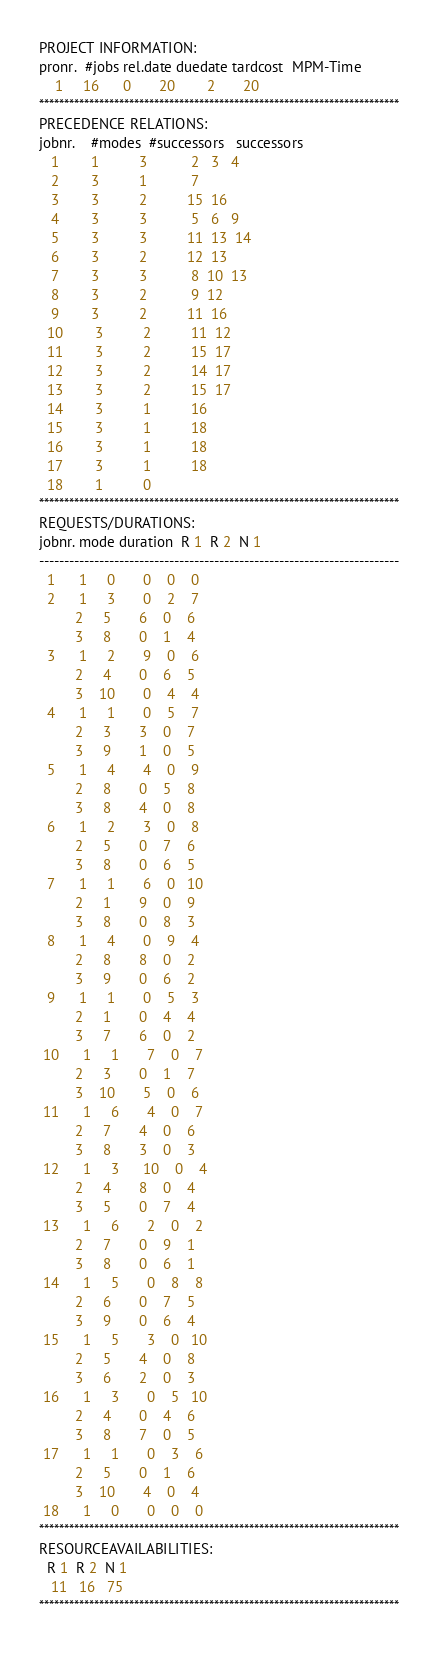Convert code to text. <code><loc_0><loc_0><loc_500><loc_500><_ObjectiveC_>PROJECT INFORMATION:
pronr.  #jobs rel.date duedate tardcost  MPM-Time
    1     16      0       20        2       20
************************************************************************
PRECEDENCE RELATIONS:
jobnr.    #modes  #successors   successors
   1        1          3           2   3   4
   2        3          1           7
   3        3          2          15  16
   4        3          3           5   6   9
   5        3          3          11  13  14
   6        3          2          12  13
   7        3          3           8  10  13
   8        3          2           9  12
   9        3          2          11  16
  10        3          2          11  12
  11        3          2          15  17
  12        3          2          14  17
  13        3          2          15  17
  14        3          1          16
  15        3          1          18
  16        3          1          18
  17        3          1          18
  18        1          0        
************************************************************************
REQUESTS/DURATIONS:
jobnr. mode duration  R 1  R 2  N 1
------------------------------------------------------------------------
  1      1     0       0    0    0
  2      1     3       0    2    7
         2     5       6    0    6
         3     8       0    1    4
  3      1     2       9    0    6
         2     4       0    6    5
         3    10       0    4    4
  4      1     1       0    5    7
         2     3       3    0    7
         3     9       1    0    5
  5      1     4       4    0    9
         2     8       0    5    8
         3     8       4    0    8
  6      1     2       3    0    8
         2     5       0    7    6
         3     8       0    6    5
  7      1     1       6    0   10
         2     1       9    0    9
         3     8       0    8    3
  8      1     4       0    9    4
         2     8       8    0    2
         3     9       0    6    2
  9      1     1       0    5    3
         2     1       0    4    4
         3     7       6    0    2
 10      1     1       7    0    7
         2     3       0    1    7
         3    10       5    0    6
 11      1     6       4    0    7
         2     7       4    0    6
         3     8       3    0    3
 12      1     3      10    0    4
         2     4       8    0    4
         3     5       0    7    4
 13      1     6       2    0    2
         2     7       0    9    1
         3     8       0    6    1
 14      1     5       0    8    8
         2     6       0    7    5
         3     9       0    6    4
 15      1     5       3    0   10
         2     5       4    0    8
         3     6       2    0    3
 16      1     3       0    5   10
         2     4       0    4    6
         3     8       7    0    5
 17      1     1       0    3    6
         2     5       0    1    6
         3    10       4    0    4
 18      1     0       0    0    0
************************************************************************
RESOURCEAVAILABILITIES:
  R 1  R 2  N 1
   11   16   75
************************************************************************
</code> 